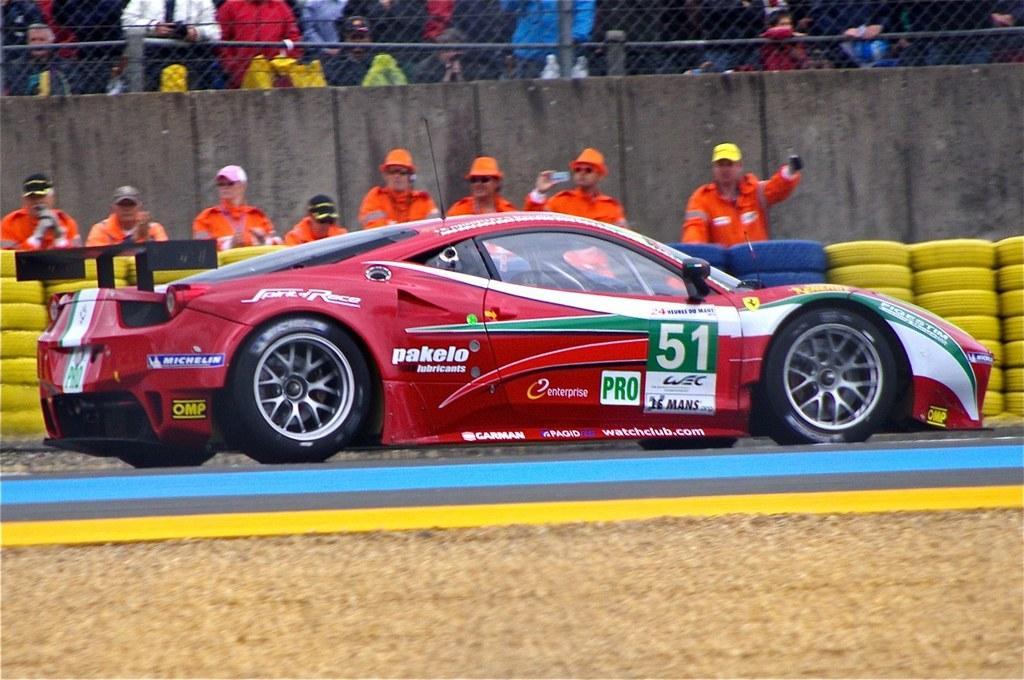Can you describe this image briefly? In the foreground of this picture, there is a sports car on the road and in the background, we can see yellow colored tyres, a stand, persons, wall, fencing and the crowd. 